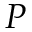Convert formula to latex. <formula><loc_0><loc_0><loc_500><loc_500>P</formula> 